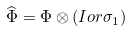<formula> <loc_0><loc_0><loc_500><loc_500>\widehat { \Phi } = \Phi \otimes ( I o r \sigma _ { 1 } )</formula> 